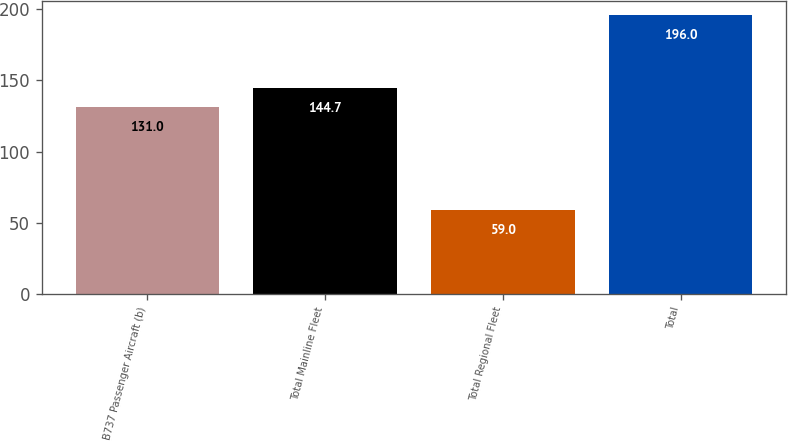Convert chart to OTSL. <chart><loc_0><loc_0><loc_500><loc_500><bar_chart><fcel>B737 Passenger Aircraft (b)<fcel>Total Mainline Fleet<fcel>Total Regional Fleet<fcel>Total<nl><fcel>131<fcel>144.7<fcel>59<fcel>196<nl></chart> 